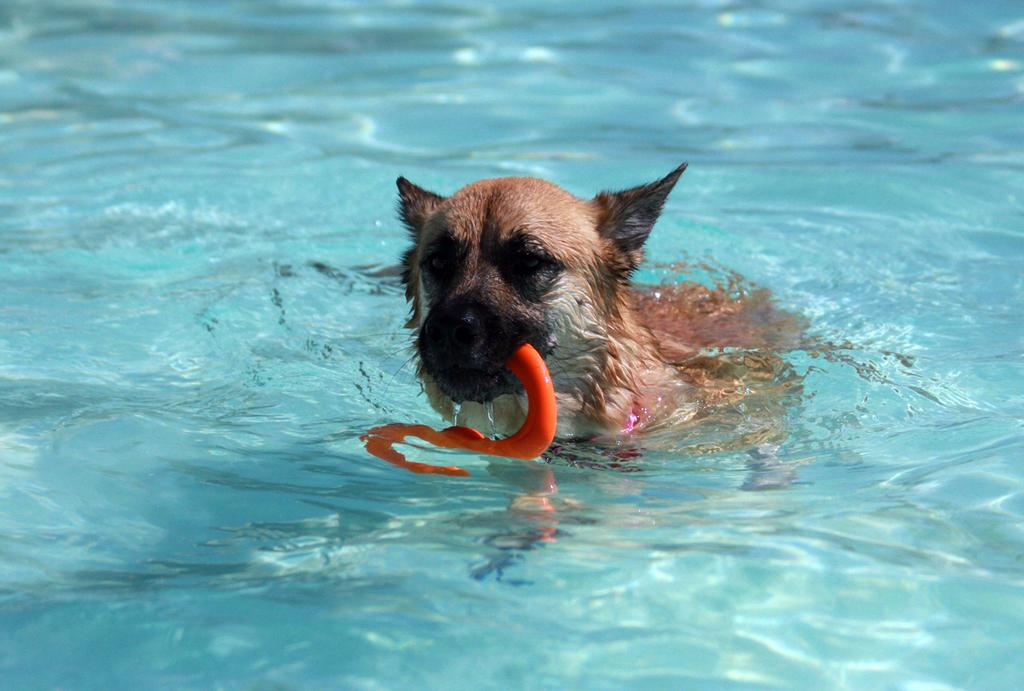What animal is present in the image? There is a dog in the image. What is the dog doing in the image? The dog is holding an object. Where is the object located in the image? The object is in the water. How does the baby contribute to the stew in the image? There is no baby or stew present in the image. 